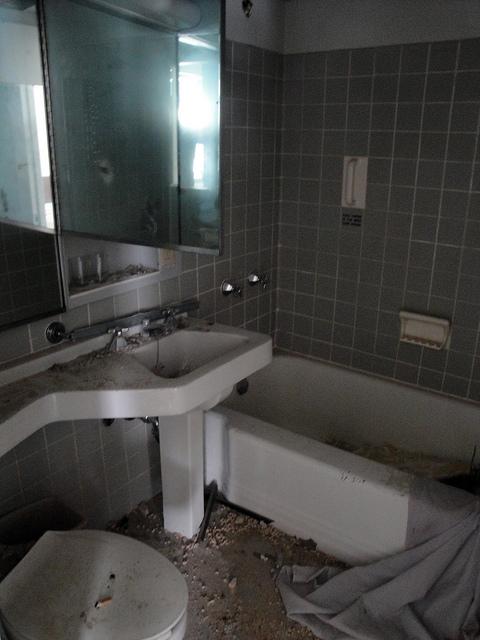What kind of flooring is in the bathroom?
Be succinct. Vinyl. Did anyone clean this bathroom?
Short answer required. No. What is the wall surrounding the tub made of?
Concise answer only. Tile. Where is the shower curtain?
Short answer required. Floor. 